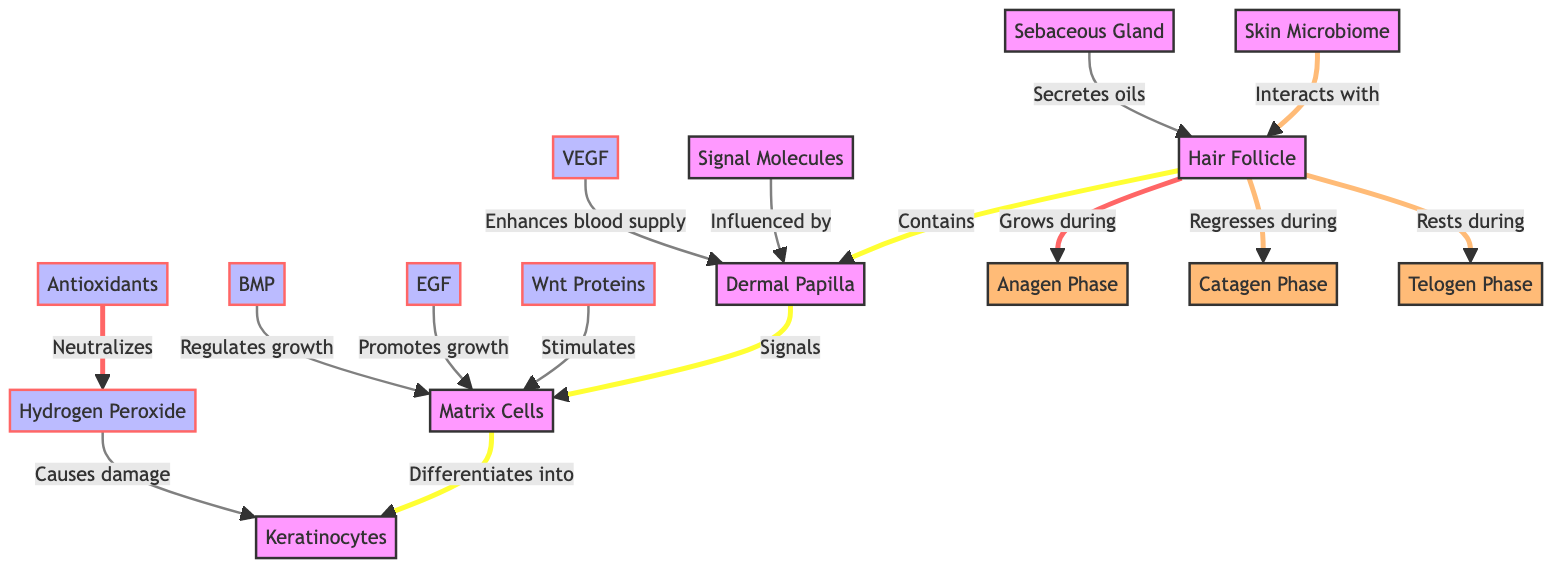How many main phases of hair growth are depicted in the diagram? The diagram includes three distinct phases of hair growth: Anagen, Catagen, and Telogen. Each phase represents a different stage in the hair growth cycle.
Answer: 3 What signals the matrix cells to differentiate into keratinocytes? According to the diagram, the dermal papilla signals the matrix cells, prompting their differentiation into keratinocytes. This relationship indicates the role of the dermal papilla in hair development.
Answer: Dermal Papilla Which protein is shown to stimulate matrix cells? The diagram indicates that Wnt proteins stimulate matrix cells, thereby promoting their activity in the hair growth process. This highlights the biochemical roles of Wnt proteins in hair development.
Answer: Wnt Proteins What is the primary effect of Hydrogen Peroxide on keratinocytes? The diagram shows that hydrogen peroxide causes damage to keratinocytes, indicating a negative impact on the cells responsible for hair structure. Understanding this relationship is important in hair care formulations.
Answer: Causes damage Which entities interact with the hair follicle according to the diagram? The diagram specifies the interactions between the skin microbiome and sebaceous glands with the hair follicle. These interactions reflect the complexity of the microenvironment affecting hair health.
Answer: Skin Microbiome, Sebaceous Gland What is the role of EGF in hair growth? The diagram illustrates that EGF promotes growth in matrix cells. This highlights the significance of epidermal growth factor in the hair growth cycle, emphasizing its relevance in hair care products.
Answer: Promotes growth How many signal molecules are depicted in the diagram? The diagram lists six signal molecules: Wnt proteins, EGF, VEGF, BMP, Hydrogen Peroxide, and Antioxidants. This categorization illustrates the various biochemical signals involved in hair growth and repair.
Answer: 6 Which phase does hair grow during? The diagram indicates that hair grows during the Anagen phase, which signifies the active growth stage of hair follicles in the hair cycle.
Answer: Anagen Phase What does the sebaceous gland secrete? The diagram states that the sebaceous gland secretes oils, which are vital for maintaining hair health and moisture levels. The presence of oils can influence hair texture and manageability.
Answer: Oils 